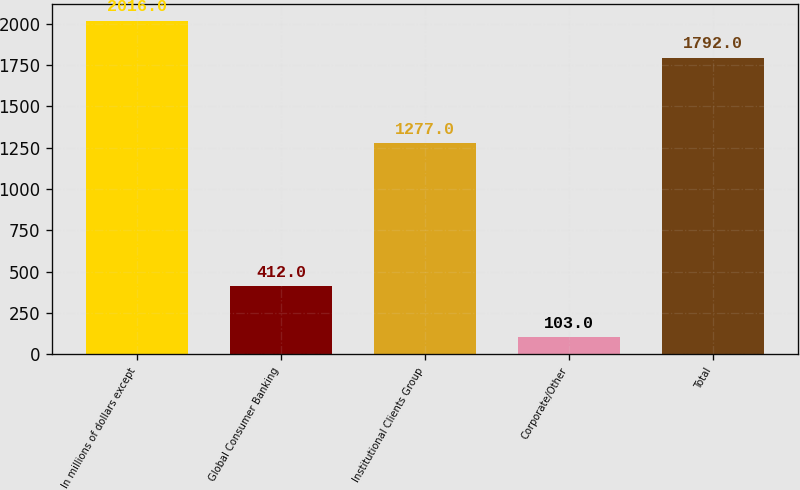<chart> <loc_0><loc_0><loc_500><loc_500><bar_chart><fcel>In millions of dollars except<fcel>Global Consumer Banking<fcel>Institutional Clients Group<fcel>Corporate/Other<fcel>Total<nl><fcel>2016<fcel>412<fcel>1277<fcel>103<fcel>1792<nl></chart> 